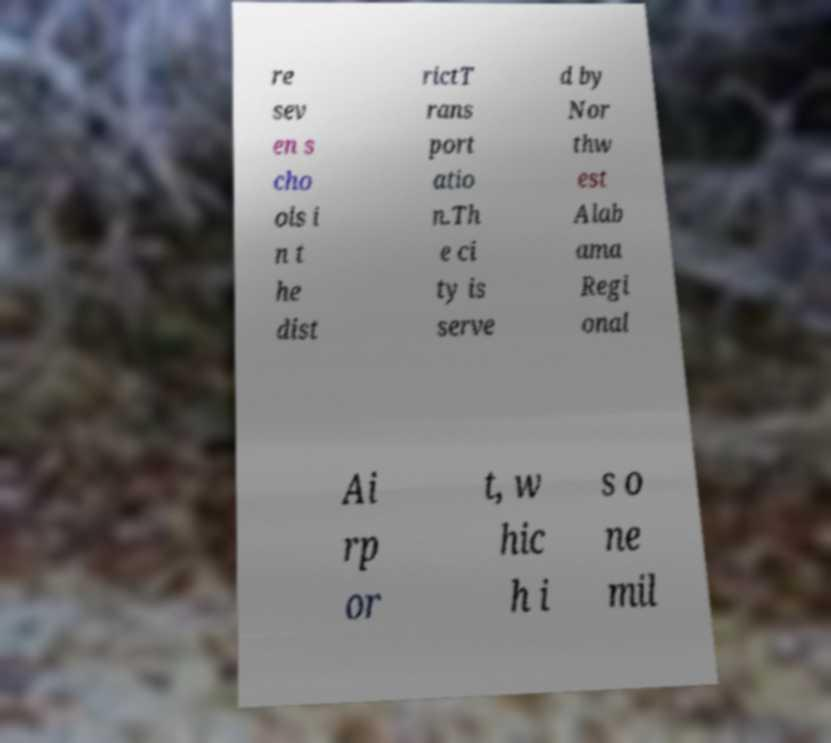Could you assist in decoding the text presented in this image and type it out clearly? re sev en s cho ols i n t he dist rictT rans port atio n.Th e ci ty is serve d by Nor thw est Alab ama Regi onal Ai rp or t, w hic h i s o ne mil 